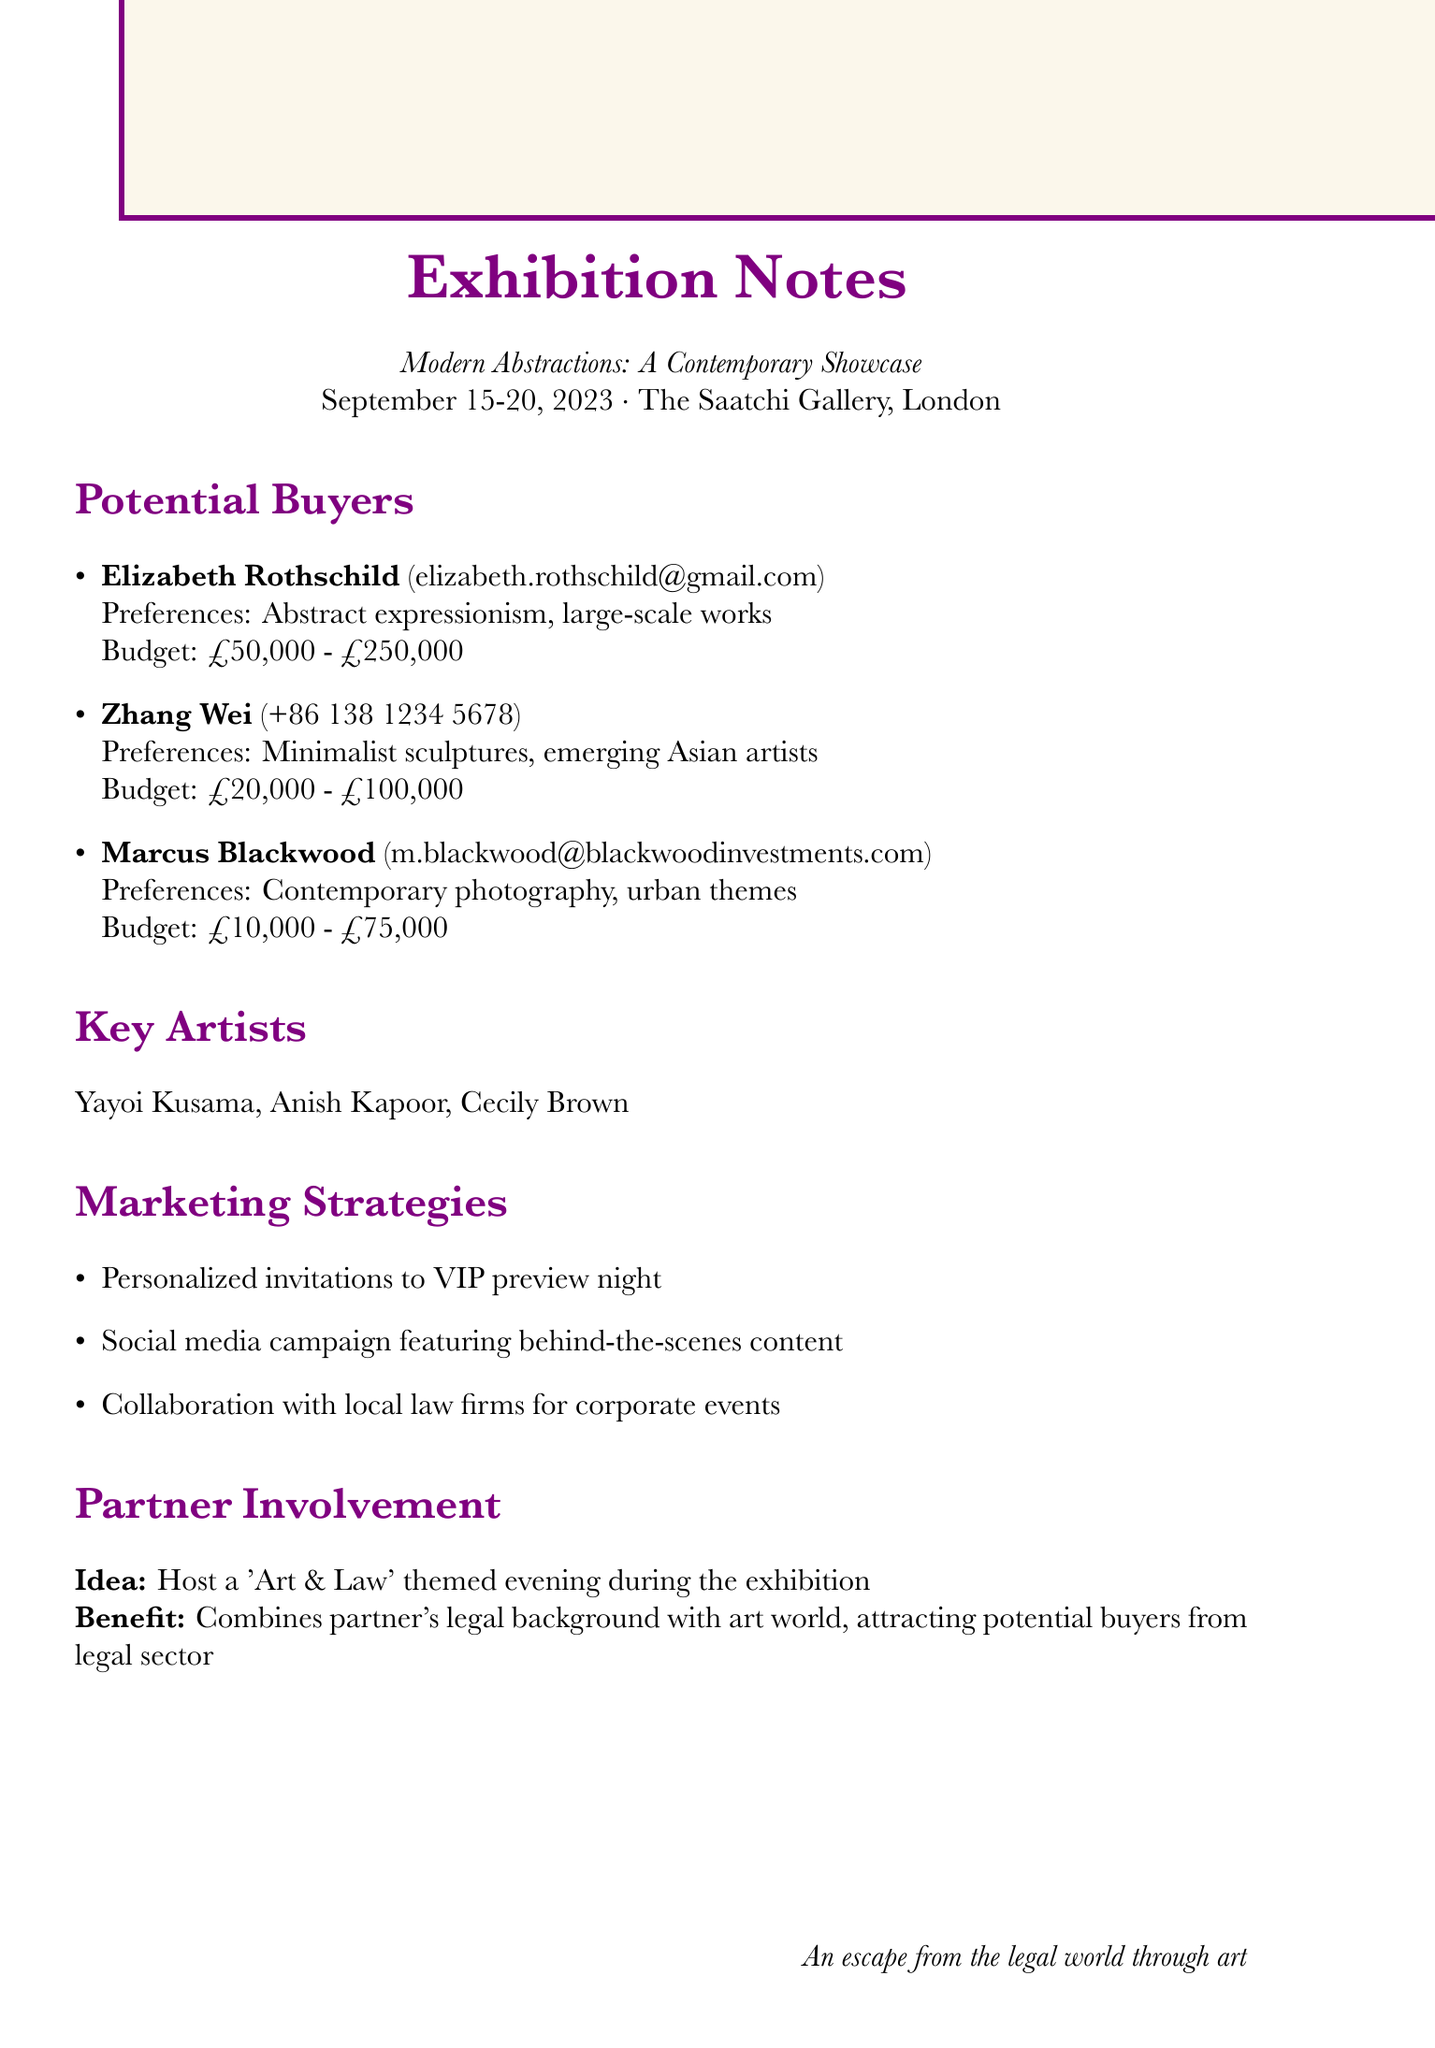What is the name of the exhibition? The exhibition is titled "Modern Abstractions: A Contemporary Showcase" according to the document.
Answer: Modern Abstractions: A Contemporary Showcase What are the dates of the exhibition? The exhibition is scheduled from September 15 to September 20, 2023.
Answer: September 15-20, 2023 Who is the first potential buyer listed? The potential buyers are listed with Elizabeth Rothschild being the first.
Answer: Elizabeth Rothschild What is Zhang Wei's budget range? The budget range for Zhang Wei is specified in the document as £20,000 to £100,000.
Answer: £20,000 - £100,000 Which artist is known for their polka dot theme? Yayoi Kusama is the artist recognized for the polka dot theme among the key artists mentioned.
Answer: Yayoi Kusama What marketing strategy involves law firms? The document mentions collaboration with local law firms for corporate events as one of the marketing strategies.
Answer: Collaboration with local law firms for corporate events What is the idea proposed for partner involvement? The idea for partner involvement mentioned in the document is to host an 'Art & Law' themed evening during the exhibition.
Answer: Host a 'Art & Law' themed evening during the exhibition What is Marcus Blackwood's preference in art? According to the preferences listed, Marcus Blackwood prefers contemporary photography with urban themes.
Answer: Contemporary photography, urban themes How many key artists are mentioned? The document lists a total of three key artists.
Answer: Three 